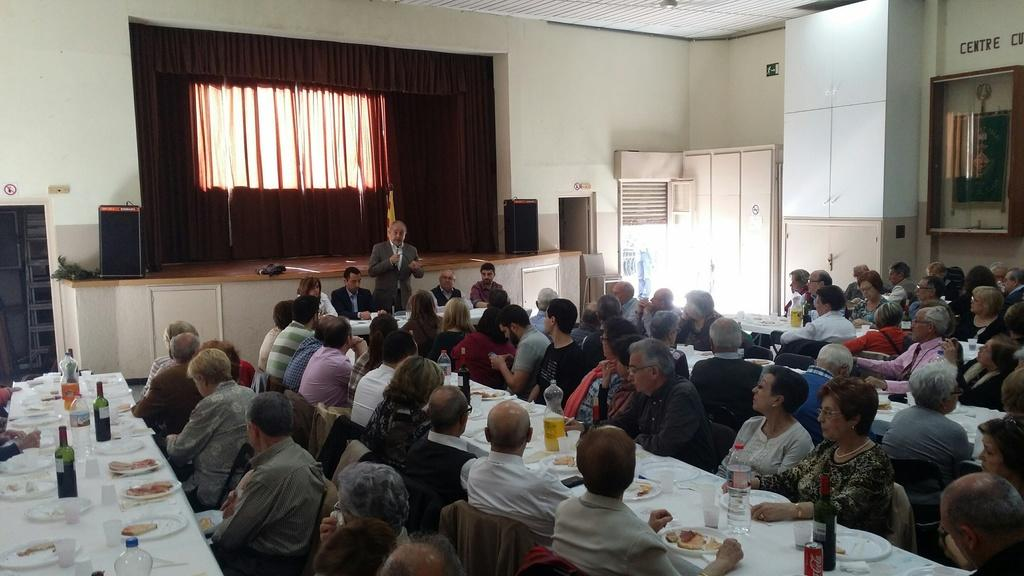What are the people in the image doing? There is a group of people sitting at tables, and they are listening to a man who is standing and speaking. Can you describe the man's actions in the image? The man is standing and speaking to the group of people sitting at tables. How are the people reacting to the man's speech? The people are listening to the man, which suggests they are engaged in what he is saying. What type of stew is being served at the tables in the image? There is no stew present in the image; it features a group of people sitting at tables and listening to a man who is standing and speaking. What discovery was made by the potato in the image? There is no potato present in the image, and therefore no discovery can be attributed to it. 